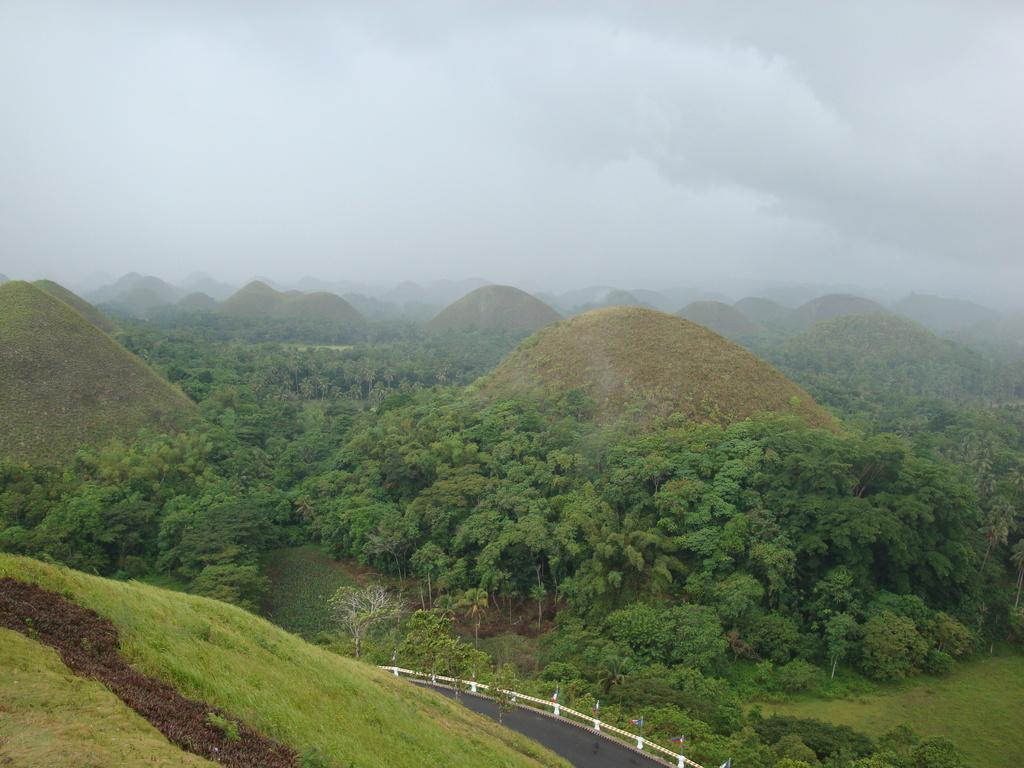What type of terrain is visible in the image? There are hills in the image. What type of vegetation can be seen in the image? There are trees and grass visible in the image. What type of barrier is present in the image? There is a fence in the image. What part of the natural environment is visible in the image? The sky is visible in the image. How many mice are sitting on the fence in the image? There are no mice present in the image. What thought is being expressed by the trees in the image? Trees do not express thoughts, as they are inanimate objects. 